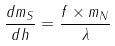Convert formula to latex. <formula><loc_0><loc_0><loc_500><loc_500>\frac { d m _ { S } } { d h } = \frac { f \times m _ { N } } { \lambda }</formula> 